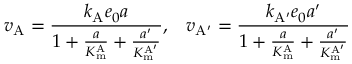<formula> <loc_0><loc_0><loc_500><loc_500>v _ { A } = { \frac { k _ { A } e _ { 0 } a } { 1 + { \frac { a } { K _ { m } ^ { A } } } + { \frac { a ^ { \prime } } { K _ { m } ^ { A ^ { \prime } } } } } } , \, v _ { A ^ { \prime } } = { \frac { k _ { A ^ { \prime } } e _ { 0 } a ^ { \prime } } { 1 + { \frac { a } { K _ { m } ^ { A } } } + { \frac { a ^ { \prime } } { K _ { m } ^ { A ^ { \prime } } } } } }</formula> 